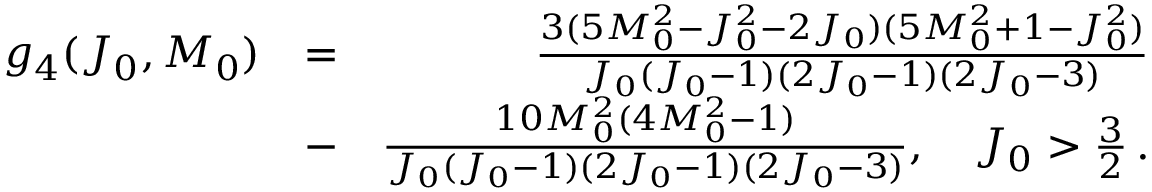<formula> <loc_0><loc_0><loc_500><loc_500>\begin{array} { r l r } { g _ { 4 } ( J _ { 0 } , M _ { 0 } ) } & { = } & { \frac { 3 ( 5 M _ { 0 } ^ { 2 } - J _ { 0 } ^ { 2 } - 2 J _ { 0 } ) ( 5 M _ { 0 } ^ { 2 } + 1 - J _ { 0 } ^ { 2 } ) } { J _ { 0 } ( J _ { 0 } - 1 ) ( 2 J _ { 0 } - 1 ) ( 2 J _ { 0 } - 3 ) } } \\ & { - } & { \frac { 1 0 M _ { 0 } ^ { 2 } ( 4 M _ { 0 } ^ { 2 } - 1 ) } { J _ { 0 } ( J _ { 0 } - 1 ) ( 2 J _ { 0 } - 1 ) ( 2 J _ { 0 } - 3 ) } , \quad J _ { 0 } > \frac { 3 } { 2 } \, . } \end{array}</formula> 